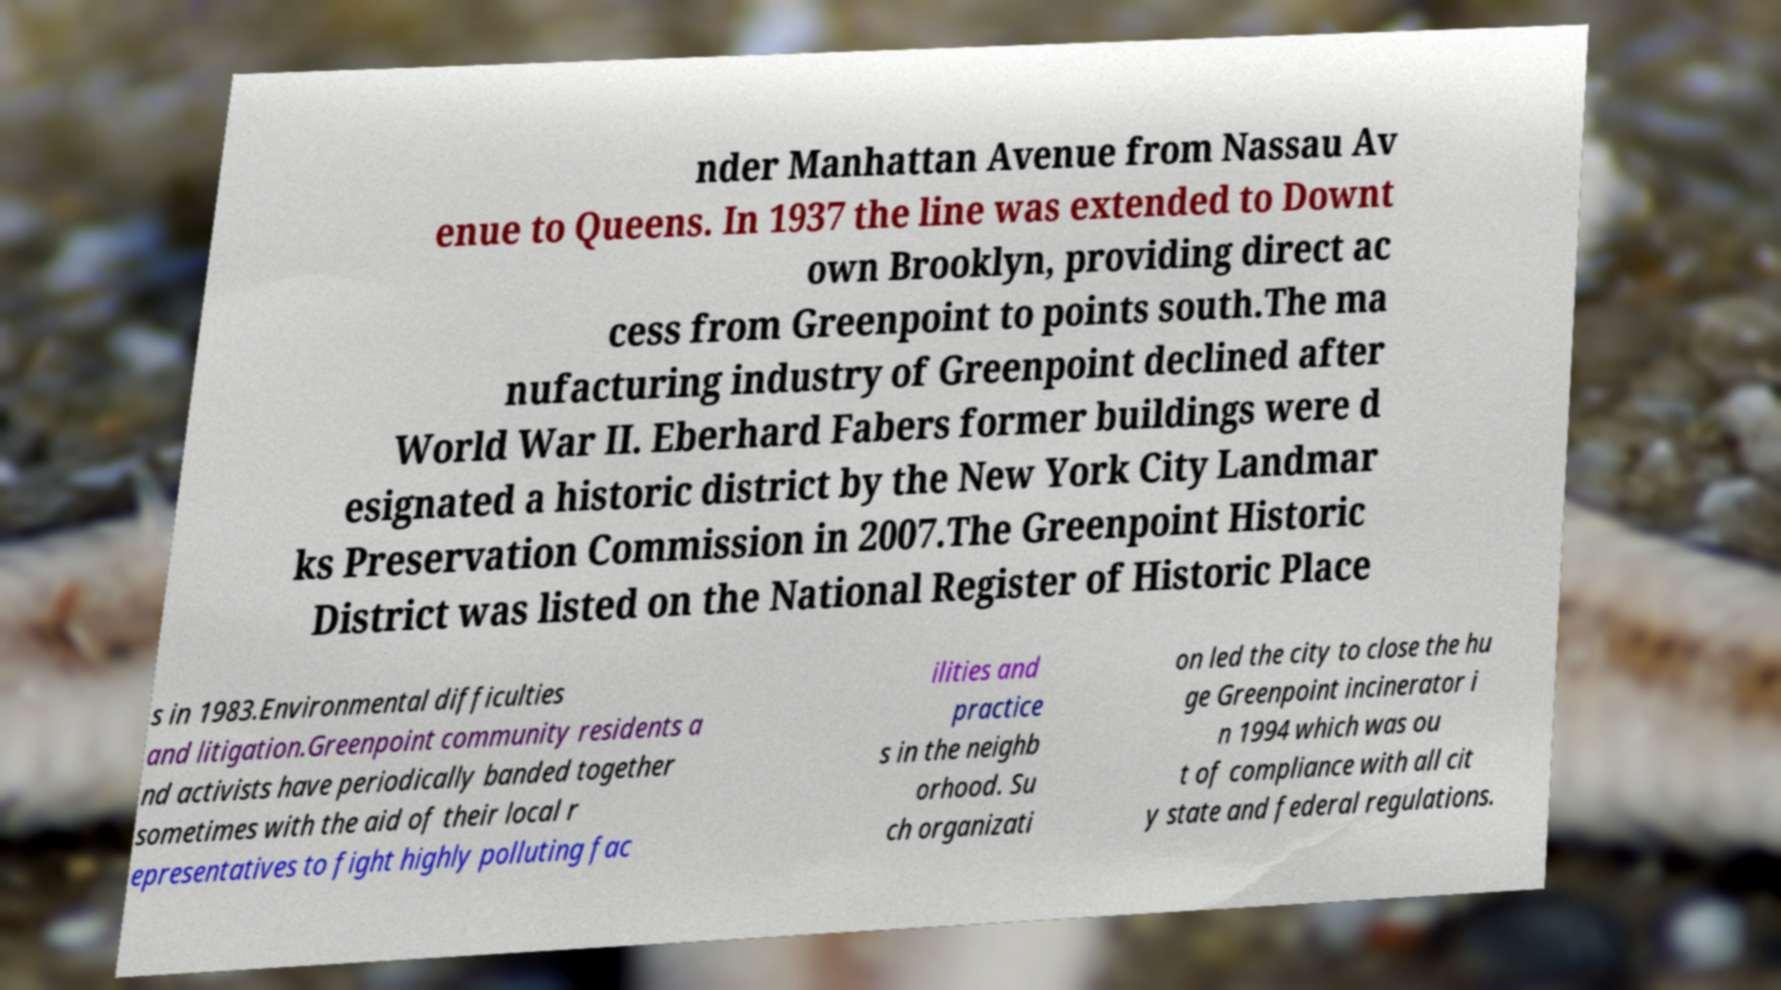Please read and relay the text visible in this image. What does it say? nder Manhattan Avenue from Nassau Av enue to Queens. In 1937 the line was extended to Downt own Brooklyn, providing direct ac cess from Greenpoint to points south.The ma nufacturing industry of Greenpoint declined after World War II. Eberhard Fabers former buildings were d esignated a historic district by the New York City Landmar ks Preservation Commission in 2007.The Greenpoint Historic District was listed on the National Register of Historic Place s in 1983.Environmental difficulties and litigation.Greenpoint community residents a nd activists have periodically banded together sometimes with the aid of their local r epresentatives to fight highly polluting fac ilities and practice s in the neighb orhood. Su ch organizati on led the city to close the hu ge Greenpoint incinerator i n 1994 which was ou t of compliance with all cit y state and federal regulations. 